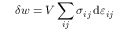Convert formula to latex. <formula><loc_0><loc_0><loc_500><loc_500>\delta w = V \sum _ { i j } \sigma _ { i j } \, d \varepsilon _ { i j }</formula> 